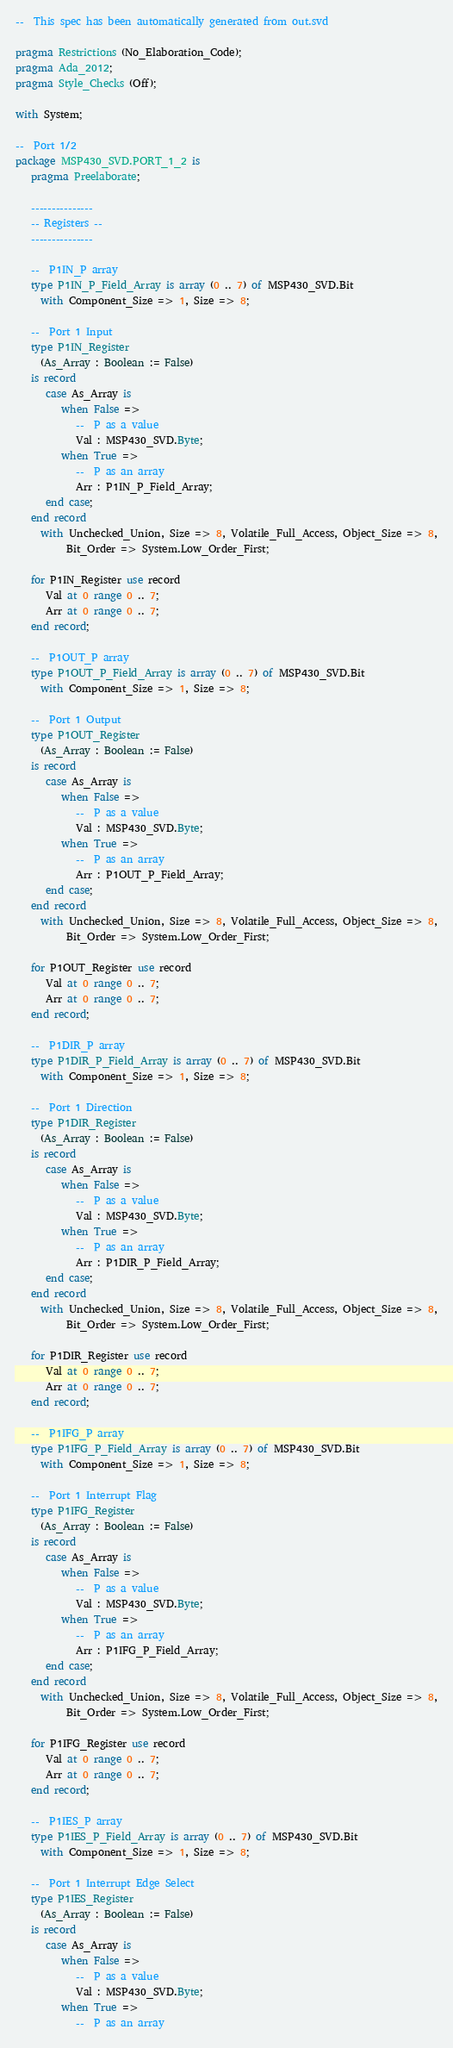Convert code to text. <code><loc_0><loc_0><loc_500><loc_500><_Ada_>--  This spec has been automatically generated from out.svd

pragma Restrictions (No_Elaboration_Code);
pragma Ada_2012;
pragma Style_Checks (Off);

with System;

--  Port 1/2
package MSP430_SVD.PORT_1_2 is
   pragma Preelaborate;

   ---------------
   -- Registers --
   ---------------

   --  P1IN_P array
   type P1IN_P_Field_Array is array (0 .. 7) of MSP430_SVD.Bit
     with Component_Size => 1, Size => 8;

   --  Port 1 Input
   type P1IN_Register
     (As_Array : Boolean := False)
   is record
      case As_Array is
         when False =>
            --  P as a value
            Val : MSP430_SVD.Byte;
         when True =>
            --  P as an array
            Arr : P1IN_P_Field_Array;
      end case;
   end record
     with Unchecked_Union, Size => 8, Volatile_Full_Access, Object_Size => 8,
          Bit_Order => System.Low_Order_First;

   for P1IN_Register use record
      Val at 0 range 0 .. 7;
      Arr at 0 range 0 .. 7;
   end record;

   --  P1OUT_P array
   type P1OUT_P_Field_Array is array (0 .. 7) of MSP430_SVD.Bit
     with Component_Size => 1, Size => 8;

   --  Port 1 Output
   type P1OUT_Register
     (As_Array : Boolean := False)
   is record
      case As_Array is
         when False =>
            --  P as a value
            Val : MSP430_SVD.Byte;
         when True =>
            --  P as an array
            Arr : P1OUT_P_Field_Array;
      end case;
   end record
     with Unchecked_Union, Size => 8, Volatile_Full_Access, Object_Size => 8,
          Bit_Order => System.Low_Order_First;

   for P1OUT_Register use record
      Val at 0 range 0 .. 7;
      Arr at 0 range 0 .. 7;
   end record;

   --  P1DIR_P array
   type P1DIR_P_Field_Array is array (0 .. 7) of MSP430_SVD.Bit
     with Component_Size => 1, Size => 8;

   --  Port 1 Direction
   type P1DIR_Register
     (As_Array : Boolean := False)
   is record
      case As_Array is
         when False =>
            --  P as a value
            Val : MSP430_SVD.Byte;
         when True =>
            --  P as an array
            Arr : P1DIR_P_Field_Array;
      end case;
   end record
     with Unchecked_Union, Size => 8, Volatile_Full_Access, Object_Size => 8,
          Bit_Order => System.Low_Order_First;

   for P1DIR_Register use record
      Val at 0 range 0 .. 7;
      Arr at 0 range 0 .. 7;
   end record;

   --  P1IFG_P array
   type P1IFG_P_Field_Array is array (0 .. 7) of MSP430_SVD.Bit
     with Component_Size => 1, Size => 8;

   --  Port 1 Interrupt Flag
   type P1IFG_Register
     (As_Array : Boolean := False)
   is record
      case As_Array is
         when False =>
            --  P as a value
            Val : MSP430_SVD.Byte;
         when True =>
            --  P as an array
            Arr : P1IFG_P_Field_Array;
      end case;
   end record
     with Unchecked_Union, Size => 8, Volatile_Full_Access, Object_Size => 8,
          Bit_Order => System.Low_Order_First;

   for P1IFG_Register use record
      Val at 0 range 0 .. 7;
      Arr at 0 range 0 .. 7;
   end record;

   --  P1IES_P array
   type P1IES_P_Field_Array is array (0 .. 7) of MSP430_SVD.Bit
     with Component_Size => 1, Size => 8;

   --  Port 1 Interrupt Edge Select
   type P1IES_Register
     (As_Array : Boolean := False)
   is record
      case As_Array is
         when False =>
            --  P as a value
            Val : MSP430_SVD.Byte;
         when True =>
            --  P as an array</code> 